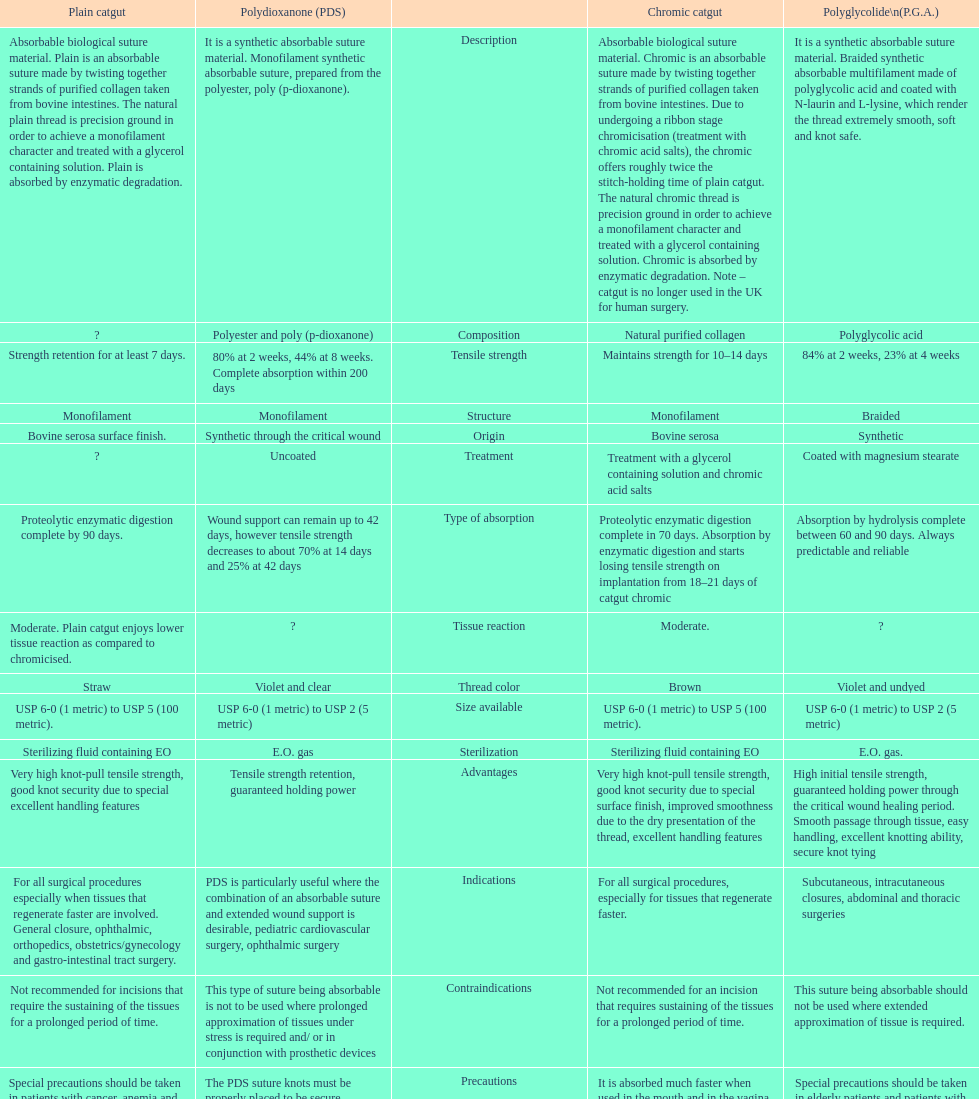Help me parse the entirety of this table. {'header': ['Plain catgut', 'Polydioxanone (PDS)', '', 'Chromic catgut', 'Polyglycolide\\n(P.G.A.)'], 'rows': [['Absorbable biological suture material. Plain is an absorbable suture made by twisting together strands of purified collagen taken from bovine intestines. The natural plain thread is precision ground in order to achieve a monofilament character and treated with a glycerol containing solution. Plain is absorbed by enzymatic degradation.', 'It is a synthetic absorbable suture material. Monofilament synthetic absorbable suture, prepared from the polyester, poly (p-dioxanone).', 'Description', 'Absorbable biological suture material. Chromic is an absorbable suture made by twisting together strands of purified collagen taken from bovine intestines. Due to undergoing a ribbon stage chromicisation (treatment with chromic acid salts), the chromic offers roughly twice the stitch-holding time of plain catgut. The natural chromic thread is precision ground in order to achieve a monofilament character and treated with a glycerol containing solution. Chromic is absorbed by enzymatic degradation. Note – catgut is no longer used in the UK for human surgery.', 'It is a synthetic absorbable suture material. Braided synthetic absorbable multifilament made of polyglycolic acid and coated with N-laurin and L-lysine, which render the thread extremely smooth, soft and knot safe.'], ['?', 'Polyester and poly (p-dioxanone)', 'Composition', 'Natural purified collagen', 'Polyglycolic acid'], ['Strength retention for at least 7 days.', '80% at 2 weeks, 44% at 8 weeks. Complete absorption within 200 days', 'Tensile strength', 'Maintains strength for 10–14 days', '84% at 2 weeks, 23% at 4 weeks'], ['Monofilament', 'Monofilament', 'Structure', 'Monofilament', 'Braided'], ['Bovine serosa surface finish.', 'Synthetic through the critical wound', 'Origin', 'Bovine serosa', 'Synthetic'], ['?', 'Uncoated', 'Treatment', 'Treatment with a glycerol containing solution and chromic acid salts', 'Coated with magnesium stearate'], ['Proteolytic enzymatic digestion complete by 90 days.', 'Wound support can remain up to 42 days, however tensile strength decreases to about 70% at 14 days and 25% at 42 days', 'Type of absorption', 'Proteolytic enzymatic digestion complete in 70 days. Absorption by enzymatic digestion and starts losing tensile strength on implantation from 18–21 days of catgut chromic', 'Absorption by hydrolysis complete between 60 and 90 days. Always predictable and reliable'], ['Moderate. Plain catgut enjoys lower tissue reaction as compared to chromicised.', '?', 'Tissue reaction', 'Moderate.', '?'], ['Straw', 'Violet and clear', 'Thread color', 'Brown', 'Violet and undyed'], ['USP 6-0 (1 metric) to USP 5 (100 metric).', 'USP 6-0 (1 metric) to USP 2 (5 metric)', 'Size available', 'USP 6-0 (1 metric) to USP 5 (100 metric).', 'USP 6-0 (1 metric) to USP 2 (5 metric)'], ['Sterilizing fluid containing EO', 'E.O. gas', 'Sterilization', 'Sterilizing fluid containing EO', 'E.O. gas.'], ['Very high knot-pull tensile strength, good knot security due to special excellent handling features', 'Tensile strength retention, guaranteed holding power', 'Advantages', 'Very high knot-pull tensile strength, good knot security due to special surface finish, improved smoothness due to the dry presentation of the thread, excellent handling features', 'High initial tensile strength, guaranteed holding power through the critical wound healing period. Smooth passage through tissue, easy handling, excellent knotting ability, secure knot tying'], ['For all surgical procedures especially when tissues that regenerate faster are involved. General closure, ophthalmic, orthopedics, obstetrics/gynecology and gastro-intestinal tract surgery.', 'PDS is particularly useful where the combination of an absorbable suture and extended wound support is desirable, pediatric cardiovascular surgery, ophthalmic surgery', 'Indications', 'For all surgical procedures, especially for tissues that regenerate faster.', 'Subcutaneous, intracutaneous closures, abdominal and thoracic surgeries'], ['Not recommended for incisions that require the sustaining of the tissues for a prolonged period of time.', 'This type of suture being absorbable is not to be used where prolonged approximation of tissues under stress is required and/ or in conjunction with prosthetic devices', 'Contraindications', 'Not recommended for an incision that requires sustaining of the tissues for a prolonged period of time.', 'This suture being absorbable should not be used where extended approximation of tissue is required.'], ['Special precautions should be taken in patients with cancer, anemia and malnutrition conditions. They tend to absorb the sutures at a higher rate. Cardiovascular surgery, due to the continued heart contractions. It is absorbed much faster when used in the mouth and in the vagina, due to the presence of microorganisms. Avoid using where long term tissue approximation is needed. Absorption is faster in infected tissues', 'The PDS suture knots must be properly placed to be secure. Conjunctival and vaginal mucosal sutures remaining in place for extended periods may be associated with localized irritation. Subcuticular sutures should be placed as deeply as possible in order to minimize the erythema and induration normally associated with absorption.', 'Precautions', 'It is absorbed much faster when used in the mouth and in the vagina, due to the presence of microorganism. Cardiovascular surgery, due to the continued heart contractions. Special precautions should be taken in patients with cancer, anemia and malnutrition conditions. They tend to absorb this suture at a higher rate.', 'Special precautions should be taken in elderly patients and patients with history of anemia and malnutrition conditions. As with any suture material, adequate knot security requires the accepted surgical technique of flat and square ties.']]} The plain catgut maintains its strength for at least how many number of days? Strength retention for at least 7 days. 